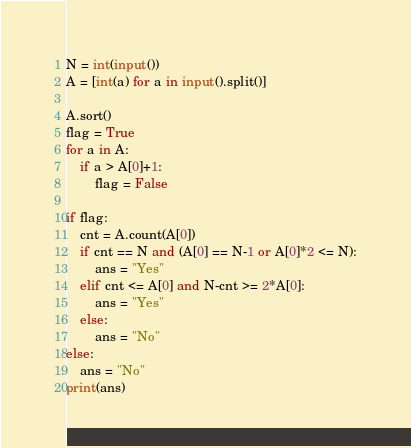<code> <loc_0><loc_0><loc_500><loc_500><_Python_>N = int(input())
A = [int(a) for a in input().split()]

A.sort()
flag = True
for a in A:
    if a > A[0]+1:
        flag = False

if flag:
    cnt = A.count(A[0])
    if cnt == N and (A[0] == N-1 or A[0]*2 <= N):
        ans = "Yes"
    elif cnt <= A[0] and N-cnt >= 2*A[0]:
        ans = "Yes"
    else:
        ans = "No"
else:
    ans = "No"
print(ans)</code> 